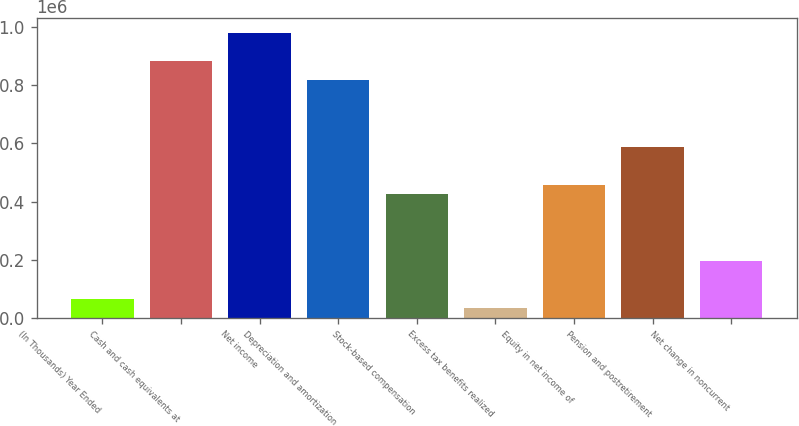Convert chart to OTSL. <chart><loc_0><loc_0><loc_500><loc_500><bar_chart><fcel>(In Thousands) Year Ended<fcel>Cash and cash equivalents at<fcel>Net income<fcel>Depreciation and amortization<fcel>Stock-based compensation<fcel>Excess tax benefits realized<fcel>Equity in net income of<fcel>Pension and postretirement<fcel>Net change in noncurrent<nl><fcel>65583.6<fcel>883004<fcel>981094<fcel>817610<fcel>425248<fcel>32886.8<fcel>457945<fcel>588732<fcel>196371<nl></chart> 